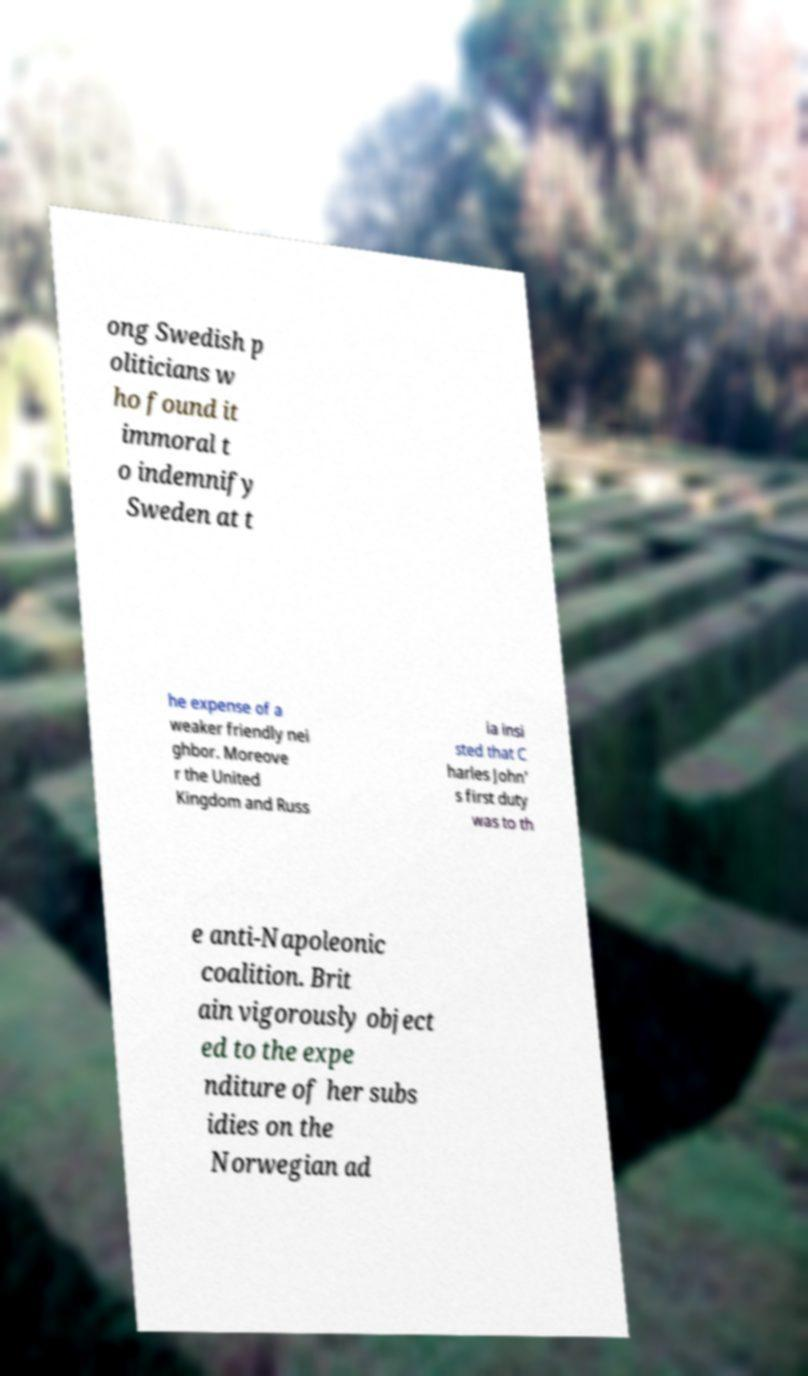Can you accurately transcribe the text from the provided image for me? ong Swedish p oliticians w ho found it immoral t o indemnify Sweden at t he expense of a weaker friendly nei ghbor. Moreove r the United Kingdom and Russ ia insi sted that C harles John' s first duty was to th e anti-Napoleonic coalition. Brit ain vigorously object ed to the expe nditure of her subs idies on the Norwegian ad 